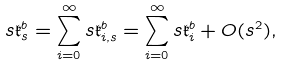Convert formula to latex. <formula><loc_0><loc_0><loc_500><loc_500>s \mathfrak { k } ^ { b } _ { s } = \sum _ { i = 0 } ^ { \infty } s \mathfrak { k } ^ { b } _ { i , s } = \sum _ { i = 0 } ^ { \infty } s \mathfrak { k } ^ { b } _ { i } + O ( s ^ { 2 } ) ,</formula> 